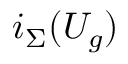Convert formula to latex. <formula><loc_0><loc_0><loc_500><loc_500>i _ { \Sigma } ( U _ { g } )</formula> 